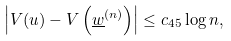<formula> <loc_0><loc_0><loc_500><loc_500>\left | V ( u ) - V \left ( \underline { w } ^ { ( n ) } \right ) \right | \leq c _ { 4 5 } \log n ,</formula> 